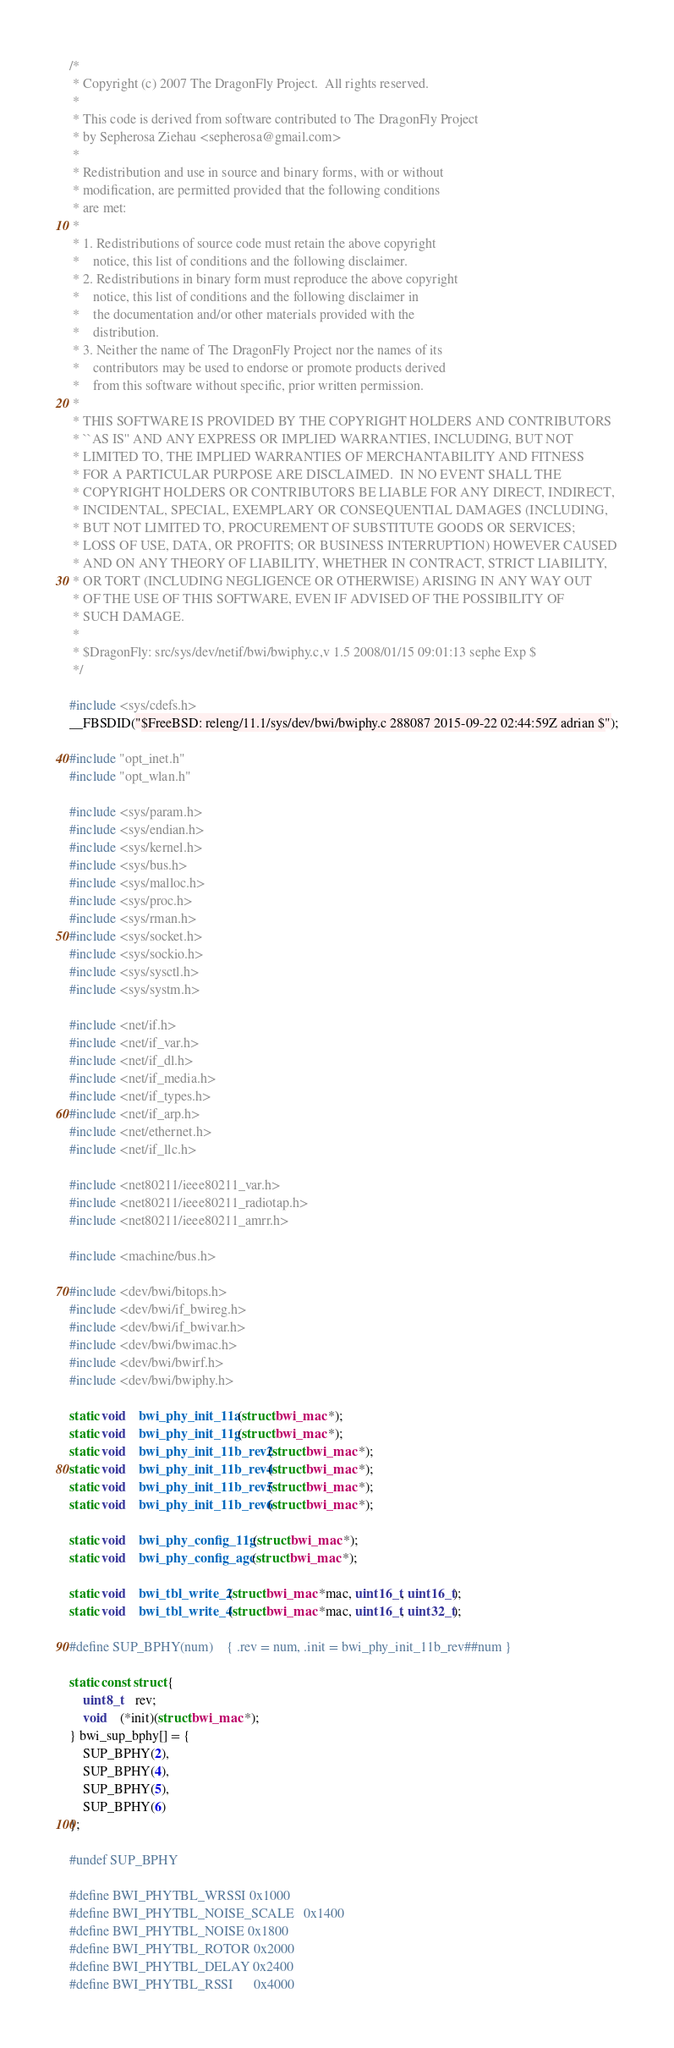Convert code to text. <code><loc_0><loc_0><loc_500><loc_500><_C_>/*
 * Copyright (c) 2007 The DragonFly Project.  All rights reserved.
 * 
 * This code is derived from software contributed to The DragonFly Project
 * by Sepherosa Ziehau <sepherosa@gmail.com>
 * 
 * Redistribution and use in source and binary forms, with or without
 * modification, are permitted provided that the following conditions
 * are met:
 * 
 * 1. Redistributions of source code must retain the above copyright
 *    notice, this list of conditions and the following disclaimer.
 * 2. Redistributions in binary form must reproduce the above copyright
 *    notice, this list of conditions and the following disclaimer in
 *    the documentation and/or other materials provided with the
 *    distribution.
 * 3. Neither the name of The DragonFly Project nor the names of its
 *    contributors may be used to endorse or promote products derived
 *    from this software without specific, prior written permission.
 * 
 * THIS SOFTWARE IS PROVIDED BY THE COPYRIGHT HOLDERS AND CONTRIBUTORS
 * ``AS IS'' AND ANY EXPRESS OR IMPLIED WARRANTIES, INCLUDING, BUT NOT
 * LIMITED TO, THE IMPLIED WARRANTIES OF MERCHANTABILITY AND FITNESS
 * FOR A PARTICULAR PURPOSE ARE DISCLAIMED.  IN NO EVENT SHALL THE
 * COPYRIGHT HOLDERS OR CONTRIBUTORS BE LIABLE FOR ANY DIRECT, INDIRECT,
 * INCIDENTAL, SPECIAL, EXEMPLARY OR CONSEQUENTIAL DAMAGES (INCLUDING,
 * BUT NOT LIMITED TO, PROCUREMENT OF SUBSTITUTE GOODS OR SERVICES;
 * LOSS OF USE, DATA, OR PROFITS; OR BUSINESS INTERRUPTION) HOWEVER CAUSED
 * AND ON ANY THEORY OF LIABILITY, WHETHER IN CONTRACT, STRICT LIABILITY,
 * OR TORT (INCLUDING NEGLIGENCE OR OTHERWISE) ARISING IN ANY WAY OUT
 * OF THE USE OF THIS SOFTWARE, EVEN IF ADVISED OF THE POSSIBILITY OF
 * SUCH DAMAGE.
 * 
 * $DragonFly: src/sys/dev/netif/bwi/bwiphy.c,v 1.5 2008/01/15 09:01:13 sephe Exp $
 */

#include <sys/cdefs.h>
__FBSDID("$FreeBSD: releng/11.1/sys/dev/bwi/bwiphy.c 288087 2015-09-22 02:44:59Z adrian $");

#include "opt_inet.h"
#include "opt_wlan.h"

#include <sys/param.h>
#include <sys/endian.h>
#include <sys/kernel.h>
#include <sys/bus.h>
#include <sys/malloc.h>
#include <sys/proc.h>
#include <sys/rman.h>
#include <sys/socket.h>
#include <sys/sockio.h>
#include <sys/sysctl.h>
#include <sys/systm.h>
 
#include <net/if.h>
#include <net/if_var.h>
#include <net/if_dl.h>
#include <net/if_media.h>
#include <net/if_types.h>
#include <net/if_arp.h>
#include <net/ethernet.h>
#include <net/if_llc.h>

#include <net80211/ieee80211_var.h>
#include <net80211/ieee80211_radiotap.h>
#include <net80211/ieee80211_amrr.h>

#include <machine/bus.h>

#include <dev/bwi/bitops.h>
#include <dev/bwi/if_bwireg.h>
#include <dev/bwi/if_bwivar.h>
#include <dev/bwi/bwimac.h>
#include <dev/bwi/bwirf.h>
#include <dev/bwi/bwiphy.h>

static void	bwi_phy_init_11a(struct bwi_mac *);
static void	bwi_phy_init_11g(struct bwi_mac *);
static void	bwi_phy_init_11b_rev2(struct bwi_mac *);
static void	bwi_phy_init_11b_rev4(struct bwi_mac *);
static void	bwi_phy_init_11b_rev5(struct bwi_mac *);
static void	bwi_phy_init_11b_rev6(struct bwi_mac *);

static void	bwi_phy_config_11g(struct bwi_mac *);
static void	bwi_phy_config_agc(struct bwi_mac *);

static void	bwi_tbl_write_2(struct bwi_mac *mac, uint16_t, uint16_t);
static void	bwi_tbl_write_4(struct bwi_mac *mac, uint16_t, uint32_t);

#define SUP_BPHY(num)	{ .rev = num, .init = bwi_phy_init_11b_rev##num }

static const struct {
	uint8_t	rev;
	void	(*init)(struct bwi_mac *);
} bwi_sup_bphy[] = {
	SUP_BPHY(2),
	SUP_BPHY(4),
	SUP_BPHY(5),
	SUP_BPHY(6)
};

#undef SUP_BPHY

#define BWI_PHYTBL_WRSSI	0x1000
#define BWI_PHYTBL_NOISE_SCALE	0x1400
#define BWI_PHYTBL_NOISE	0x1800
#define BWI_PHYTBL_ROTOR	0x2000
#define BWI_PHYTBL_DELAY	0x2400
#define BWI_PHYTBL_RSSI		0x4000</code> 